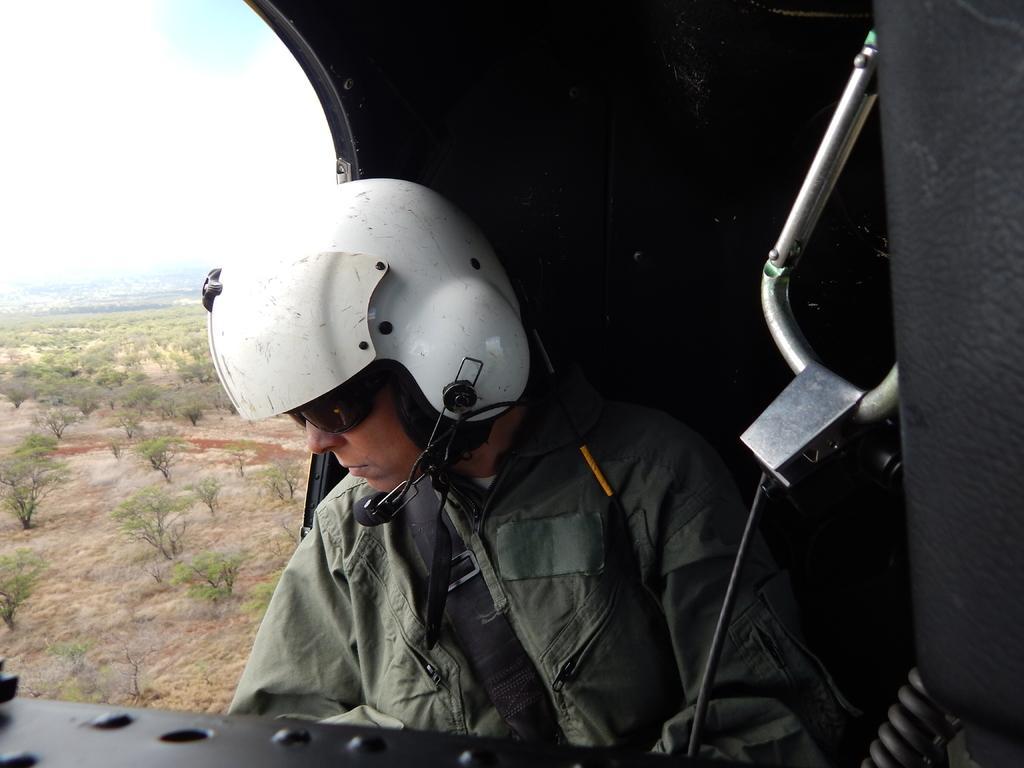Could you give a brief overview of what you see in this image? In the image we can see a person wearing clothes, helmet and goggles, he is sitting. This is a flying jet, tree, grass and a sky. 